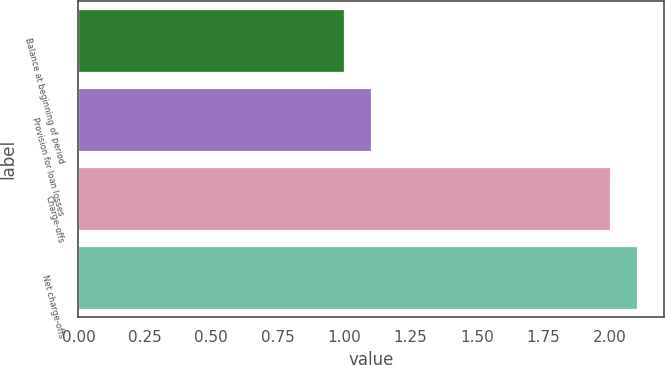Convert chart. <chart><loc_0><loc_0><loc_500><loc_500><bar_chart><fcel>Balance at beginning of period<fcel>Provision for loan losses<fcel>Charge-offs<fcel>Net charge-offs<nl><fcel>1<fcel>1.1<fcel>2<fcel>2.1<nl></chart> 